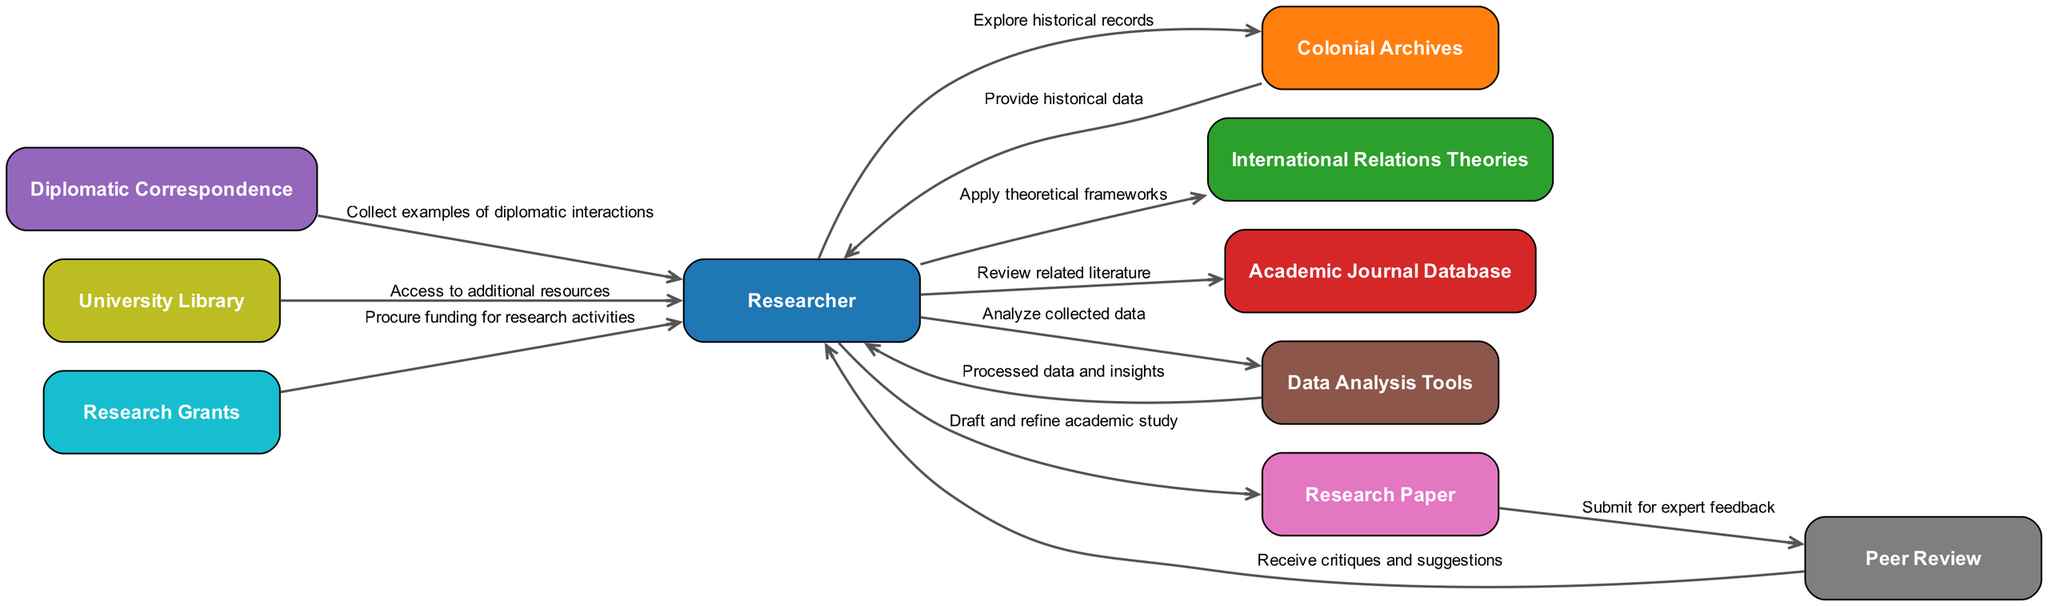What is the total number of nodes in the diagram? The diagram includes all entities involved in the academic research workflow; counting them shows there are ten nodes shown.
Answer: Ten What does the Researcher submit to the Peer Review? According to the diagram, the Researcher submits the Research Paper to the Peer Review stage for feedback.
Answer: Research Paper What historical resource does the Researcher explore? The diagram indicates that the Researcher explores the Colonial Archives for historical records and documents related to the research topic.
Answer: Colonial Archives How does the Researcher obtain funding for research activities? The diagram shows that the Researcher receives Research Grants to procure funding necessary for the research activities outlined in their workflow.
Answer: Research Grants What flow connects Data Analysis Tools back to the Researcher? The Data Analysis Tools provide Processed Data and Insights back to the Researcher, following the data analysis.
Answer: Processed Data and Insights Which entity provides access to additional resources to the Researcher? The University Library is indicated in the diagram as the entity that provides access to additional resources for the Researcher to support their research.
Answer: University Library How many flows originate from the Researcher? By reviewing the diagram, one can count the various connections originating from the Researcher, and it shows there are five outgoing flows from the Researcher.
Answer: Five What type of feedback does the Researcher receive from the Peer Review? The diagram indicates that the Researcher receives critiques and suggestions from the Peer Review process, as a form of feedback from other experts.
Answer: Critiques and suggestions What type of correspondence is collected by the Researcher? The Researcher collects Diplomatic Correspondence, as detailed in the flow diagram connecting Diplomatic Correspondence to the Researcher.
Answer: Diplomatic Correspondence 